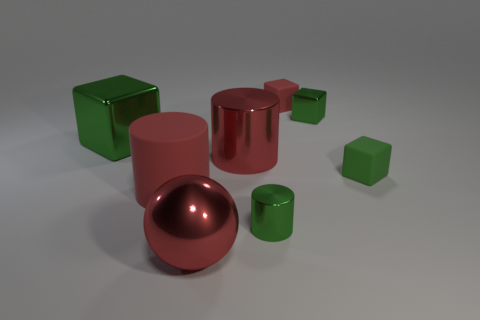There is a large red matte cylinder; how many small green objects are in front of it?
Keep it short and to the point. 1. What number of other things are there of the same color as the large shiny cylinder?
Your answer should be very brief. 3. Is the number of large matte things that are on the right side of the red ball less than the number of small rubber things to the left of the green cylinder?
Your response must be concise. No. How many things are green shiny cubes on the left side of the small red block or large yellow rubber things?
Your answer should be very brief. 1. There is a green matte object; is its size the same as the metallic cylinder behind the large red rubber cylinder?
Your answer should be compact. No. There is a green matte object that is the same shape as the tiny red object; what size is it?
Provide a short and direct response. Small. How many tiny green metal cylinders are to the right of the matte object behind the small rubber block in front of the large green block?
Give a very brief answer. 0. How many blocks are tiny green matte things or green things?
Offer a very short reply. 3. There is a tiny shiny object that is left of the red matte thing that is on the right side of the tiny green metallic thing that is in front of the big block; what color is it?
Provide a succinct answer. Green. What number of other objects are the same size as the metallic ball?
Provide a succinct answer. 3. 